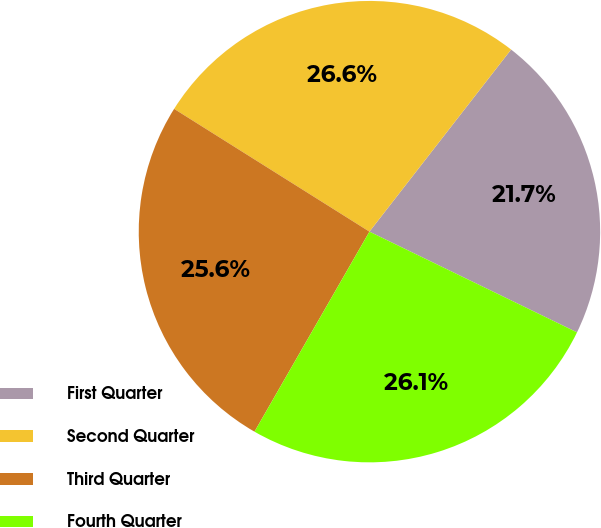Convert chart. <chart><loc_0><loc_0><loc_500><loc_500><pie_chart><fcel>First Quarter<fcel>Second Quarter<fcel>Third Quarter<fcel>Fourth Quarter<nl><fcel>21.67%<fcel>26.59%<fcel>25.63%<fcel>26.11%<nl></chart> 